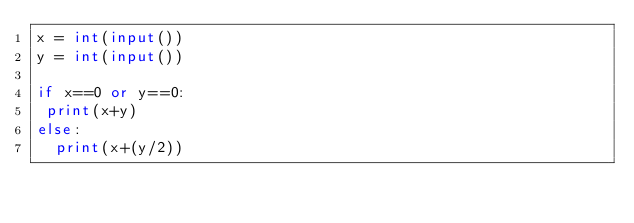<code> <loc_0><loc_0><loc_500><loc_500><_Python_>x = int(input())
y = int(input())

if x==0 or y==0:
 print(x+y)
else:
  print(x+(y/2))</code> 